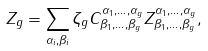Convert formula to latex. <formula><loc_0><loc_0><loc_500><loc_500>Z _ { g } = \sum _ { \alpha _ { i } , \beta _ { i } } \zeta _ { g } C _ { \beta _ { 1 } , \dots , \beta _ { g } } ^ { \alpha _ { 1 } , \dots , \alpha _ { g } } Z _ { \beta _ { 1 } , \dots , \beta _ { g } } ^ { \alpha _ { 1 } , \dots , \alpha _ { g } } ,</formula> 